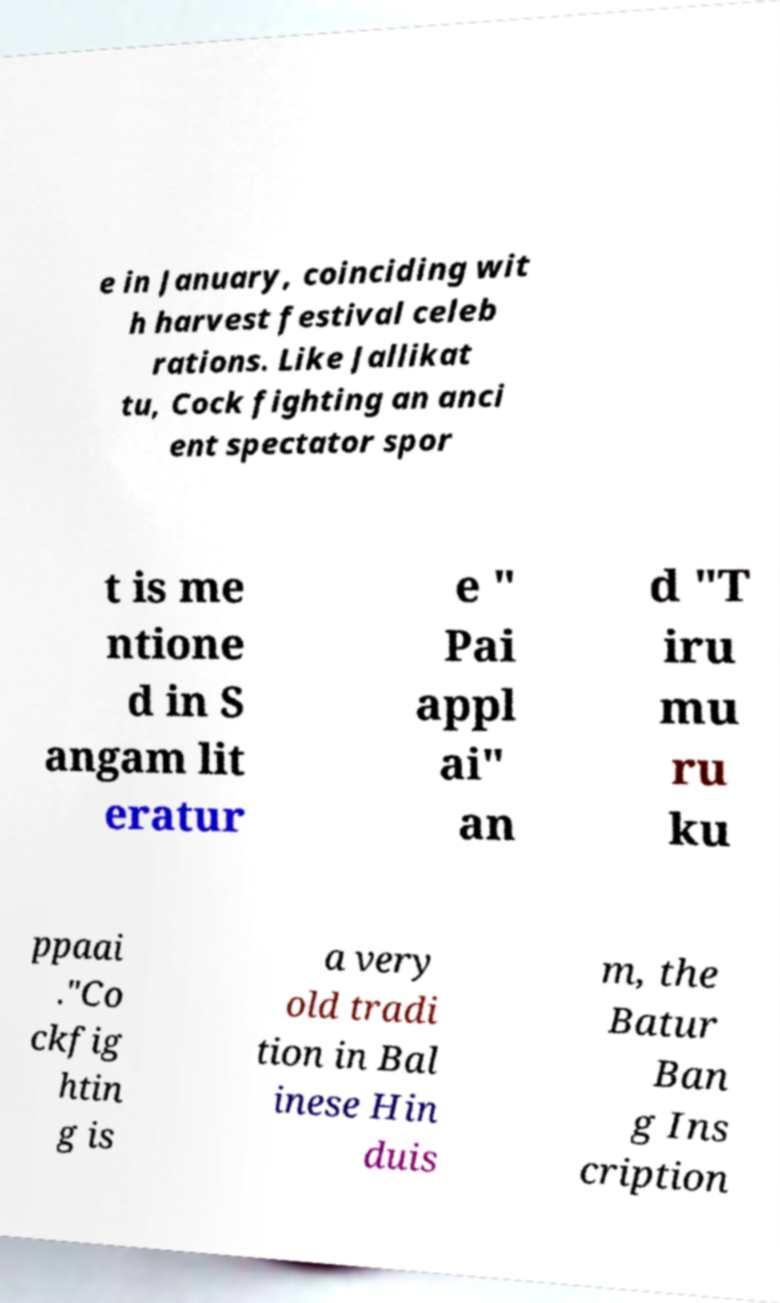What messages or text are displayed in this image? I need them in a readable, typed format. e in January, coinciding wit h harvest festival celeb rations. Like Jallikat tu, Cock fighting an anci ent spectator spor t is me ntione d in S angam lit eratur e " Pai appl ai" an d "T iru mu ru ku ppaai ."Co ckfig htin g is a very old tradi tion in Bal inese Hin duis m, the Batur Ban g Ins cription 